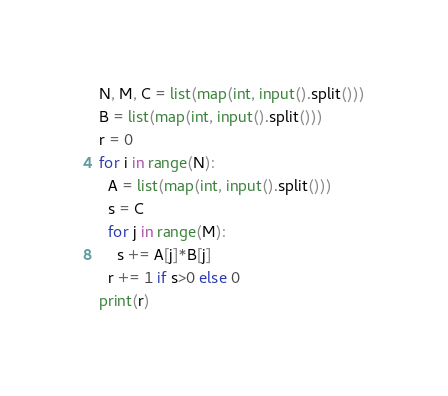Convert code to text. <code><loc_0><loc_0><loc_500><loc_500><_Python_>N, M, C = list(map(int, input().split()))
B = list(map(int, input().split()))
r = 0
for i in range(N):
  A = list(map(int, input().split()))
  s = C
  for j in range(M):
    s += A[j]*B[j]
  r += 1 if s>0 else 0
print(r)</code> 